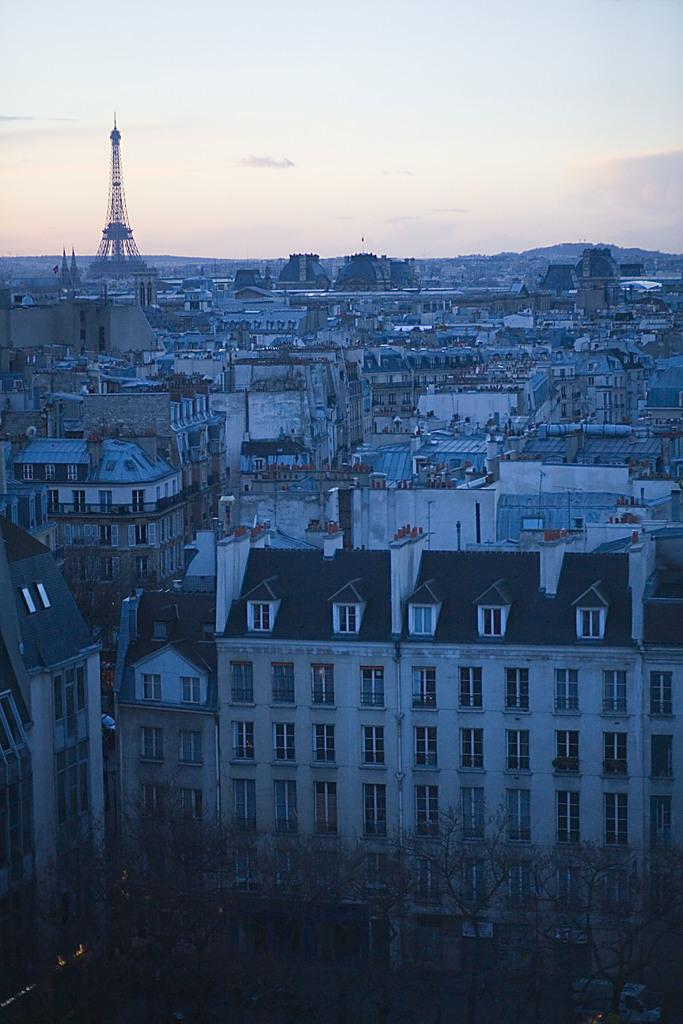What type of natural elements can be seen in the image? There are trees in the image. What type of man-made structures are present in the image? There are buildings and a tower in the image. What mode of transportation can be seen in the image? There is a vehicle in the image. What is visible in the background of the image? The sky is visible in the background of the image. Is there a baseball game taking place in the image? There is no indication of a baseball game or any sports activity in the image. What is the slope of the road in the image? There is no road or slope present in the image; it features trees, buildings, a tower, and a vehicle. 